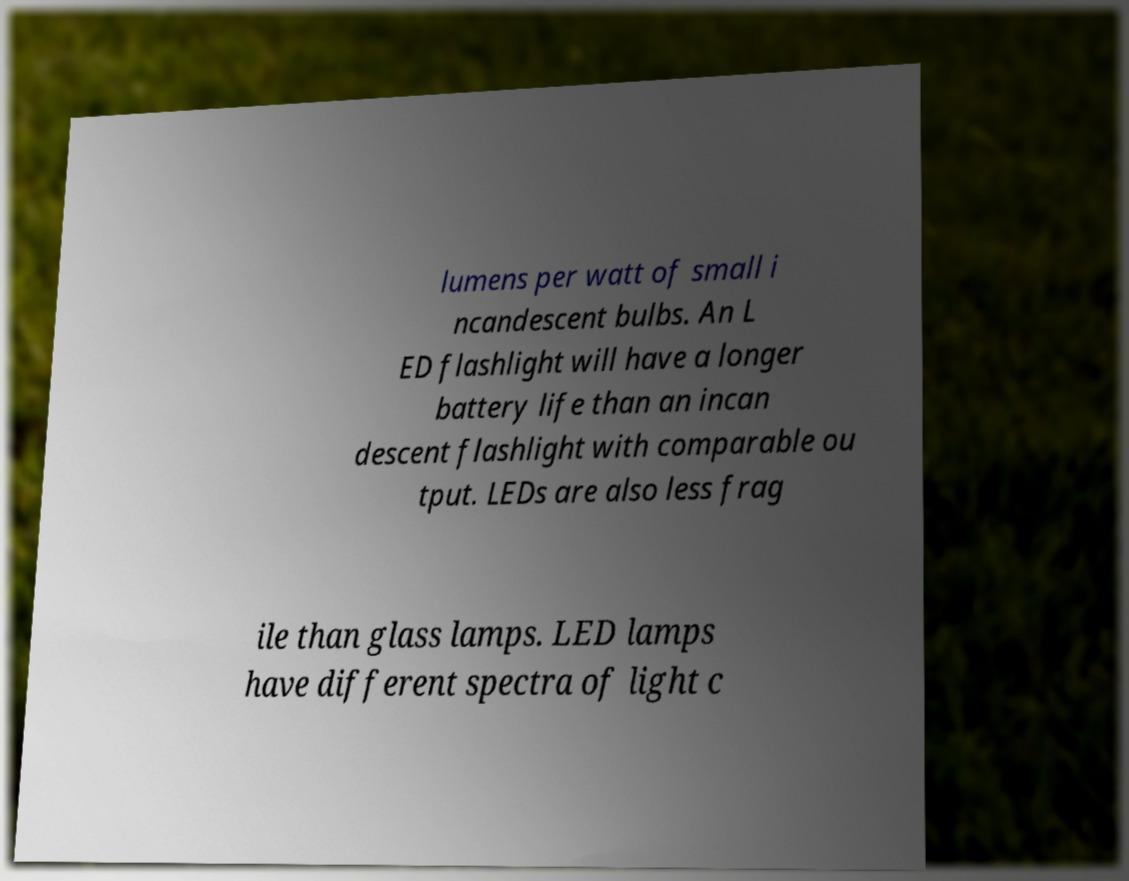Could you extract and type out the text from this image? lumens per watt of small i ncandescent bulbs. An L ED flashlight will have a longer battery life than an incan descent flashlight with comparable ou tput. LEDs are also less frag ile than glass lamps. LED lamps have different spectra of light c 